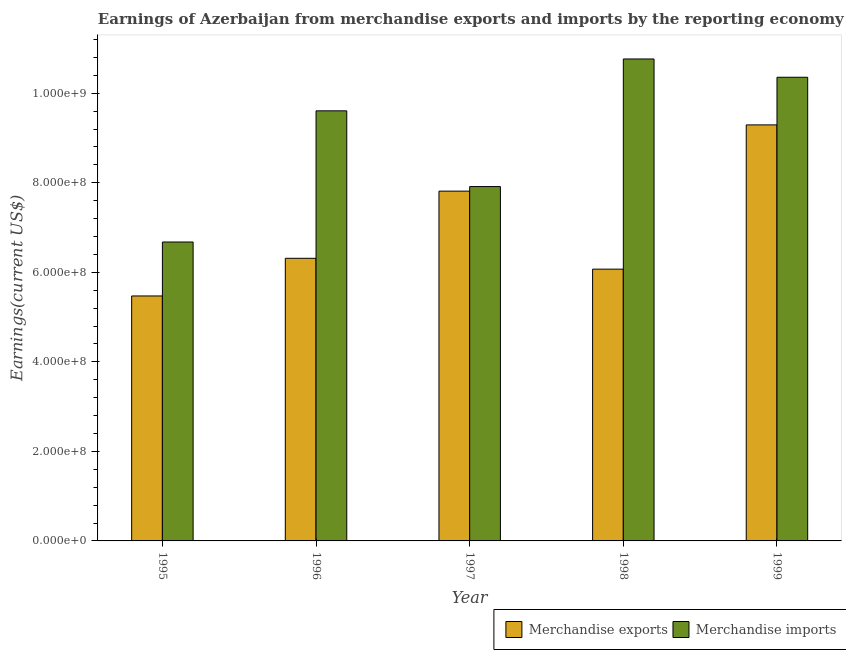How many different coloured bars are there?
Offer a very short reply. 2. How many groups of bars are there?
Keep it short and to the point. 5. What is the label of the 4th group of bars from the left?
Offer a very short reply. 1998. What is the earnings from merchandise imports in 1999?
Your answer should be very brief. 1.04e+09. Across all years, what is the maximum earnings from merchandise imports?
Provide a short and direct response. 1.08e+09. Across all years, what is the minimum earnings from merchandise exports?
Your answer should be compact. 5.47e+08. In which year was the earnings from merchandise exports maximum?
Offer a terse response. 1999. What is the total earnings from merchandise exports in the graph?
Your answer should be compact. 3.50e+09. What is the difference between the earnings from merchandise imports in 1995 and that in 1997?
Your answer should be very brief. -1.24e+08. What is the difference between the earnings from merchandise imports in 1997 and the earnings from merchandise exports in 1999?
Give a very brief answer. -2.44e+08. What is the average earnings from merchandise imports per year?
Offer a terse response. 9.06e+08. In how many years, is the earnings from merchandise exports greater than 480000000 US$?
Your answer should be compact. 5. What is the ratio of the earnings from merchandise imports in 1995 to that in 1998?
Offer a terse response. 0.62. Is the earnings from merchandise exports in 1995 less than that in 1996?
Your answer should be compact. Yes. What is the difference between the highest and the second highest earnings from merchandise exports?
Offer a very short reply. 1.48e+08. What is the difference between the highest and the lowest earnings from merchandise exports?
Offer a very short reply. 3.82e+08. In how many years, is the earnings from merchandise exports greater than the average earnings from merchandise exports taken over all years?
Keep it short and to the point. 2. Is the sum of the earnings from merchandise exports in 1995 and 1998 greater than the maximum earnings from merchandise imports across all years?
Your response must be concise. Yes. What does the 2nd bar from the left in 1995 represents?
Give a very brief answer. Merchandise imports. What does the 2nd bar from the right in 1996 represents?
Provide a succinct answer. Merchandise exports. How many bars are there?
Ensure brevity in your answer.  10. What is the difference between two consecutive major ticks on the Y-axis?
Offer a very short reply. 2.00e+08. Are the values on the major ticks of Y-axis written in scientific E-notation?
Make the answer very short. Yes. Does the graph contain any zero values?
Keep it short and to the point. No. Does the graph contain grids?
Your response must be concise. No. How many legend labels are there?
Offer a terse response. 2. What is the title of the graph?
Provide a succinct answer. Earnings of Azerbaijan from merchandise exports and imports by the reporting economy. What is the label or title of the X-axis?
Offer a very short reply. Year. What is the label or title of the Y-axis?
Offer a very short reply. Earnings(current US$). What is the Earnings(current US$) of Merchandise exports in 1995?
Your answer should be very brief. 5.47e+08. What is the Earnings(current US$) of Merchandise imports in 1995?
Your answer should be very brief. 6.68e+08. What is the Earnings(current US$) in Merchandise exports in 1996?
Make the answer very short. 6.31e+08. What is the Earnings(current US$) in Merchandise imports in 1996?
Make the answer very short. 9.61e+08. What is the Earnings(current US$) in Merchandise exports in 1997?
Make the answer very short. 7.81e+08. What is the Earnings(current US$) in Merchandise imports in 1997?
Provide a short and direct response. 7.91e+08. What is the Earnings(current US$) of Merchandise exports in 1998?
Give a very brief answer. 6.07e+08. What is the Earnings(current US$) in Merchandise imports in 1998?
Keep it short and to the point. 1.08e+09. What is the Earnings(current US$) in Merchandise exports in 1999?
Offer a very short reply. 9.29e+08. What is the Earnings(current US$) of Merchandise imports in 1999?
Make the answer very short. 1.04e+09. Across all years, what is the maximum Earnings(current US$) in Merchandise exports?
Provide a short and direct response. 9.29e+08. Across all years, what is the maximum Earnings(current US$) in Merchandise imports?
Ensure brevity in your answer.  1.08e+09. Across all years, what is the minimum Earnings(current US$) of Merchandise exports?
Provide a succinct answer. 5.47e+08. Across all years, what is the minimum Earnings(current US$) in Merchandise imports?
Make the answer very short. 6.68e+08. What is the total Earnings(current US$) in Merchandise exports in the graph?
Your answer should be very brief. 3.50e+09. What is the total Earnings(current US$) of Merchandise imports in the graph?
Offer a very short reply. 4.53e+09. What is the difference between the Earnings(current US$) in Merchandise exports in 1995 and that in 1996?
Make the answer very short. -8.41e+07. What is the difference between the Earnings(current US$) in Merchandise imports in 1995 and that in 1996?
Your answer should be very brief. -2.93e+08. What is the difference between the Earnings(current US$) in Merchandise exports in 1995 and that in 1997?
Provide a short and direct response. -2.34e+08. What is the difference between the Earnings(current US$) in Merchandise imports in 1995 and that in 1997?
Your answer should be compact. -1.24e+08. What is the difference between the Earnings(current US$) in Merchandise exports in 1995 and that in 1998?
Offer a terse response. -5.99e+07. What is the difference between the Earnings(current US$) in Merchandise imports in 1995 and that in 1998?
Keep it short and to the point. -4.09e+08. What is the difference between the Earnings(current US$) of Merchandise exports in 1995 and that in 1999?
Your answer should be very brief. -3.82e+08. What is the difference between the Earnings(current US$) of Merchandise imports in 1995 and that in 1999?
Your answer should be very brief. -3.68e+08. What is the difference between the Earnings(current US$) in Merchandise exports in 1996 and that in 1997?
Provide a short and direct response. -1.50e+08. What is the difference between the Earnings(current US$) in Merchandise imports in 1996 and that in 1997?
Your answer should be very brief. 1.69e+08. What is the difference between the Earnings(current US$) in Merchandise exports in 1996 and that in 1998?
Keep it short and to the point. 2.42e+07. What is the difference between the Earnings(current US$) of Merchandise imports in 1996 and that in 1998?
Your answer should be very brief. -1.16e+08. What is the difference between the Earnings(current US$) in Merchandise exports in 1996 and that in 1999?
Provide a succinct answer. -2.98e+08. What is the difference between the Earnings(current US$) of Merchandise imports in 1996 and that in 1999?
Keep it short and to the point. -7.50e+07. What is the difference between the Earnings(current US$) of Merchandise exports in 1997 and that in 1998?
Ensure brevity in your answer.  1.74e+08. What is the difference between the Earnings(current US$) in Merchandise imports in 1997 and that in 1998?
Provide a succinct answer. -2.85e+08. What is the difference between the Earnings(current US$) of Merchandise exports in 1997 and that in 1999?
Offer a very short reply. -1.48e+08. What is the difference between the Earnings(current US$) in Merchandise imports in 1997 and that in 1999?
Provide a short and direct response. -2.44e+08. What is the difference between the Earnings(current US$) of Merchandise exports in 1998 and that in 1999?
Provide a short and direct response. -3.22e+08. What is the difference between the Earnings(current US$) of Merchandise imports in 1998 and that in 1999?
Give a very brief answer. 4.08e+07. What is the difference between the Earnings(current US$) in Merchandise exports in 1995 and the Earnings(current US$) in Merchandise imports in 1996?
Offer a terse response. -4.13e+08. What is the difference between the Earnings(current US$) of Merchandise exports in 1995 and the Earnings(current US$) of Merchandise imports in 1997?
Keep it short and to the point. -2.44e+08. What is the difference between the Earnings(current US$) of Merchandise exports in 1995 and the Earnings(current US$) of Merchandise imports in 1998?
Offer a very short reply. -5.29e+08. What is the difference between the Earnings(current US$) of Merchandise exports in 1995 and the Earnings(current US$) of Merchandise imports in 1999?
Provide a succinct answer. -4.89e+08. What is the difference between the Earnings(current US$) in Merchandise exports in 1996 and the Earnings(current US$) in Merchandise imports in 1997?
Ensure brevity in your answer.  -1.60e+08. What is the difference between the Earnings(current US$) of Merchandise exports in 1996 and the Earnings(current US$) of Merchandise imports in 1998?
Your response must be concise. -4.45e+08. What is the difference between the Earnings(current US$) in Merchandise exports in 1996 and the Earnings(current US$) in Merchandise imports in 1999?
Ensure brevity in your answer.  -4.04e+08. What is the difference between the Earnings(current US$) of Merchandise exports in 1997 and the Earnings(current US$) of Merchandise imports in 1998?
Offer a terse response. -2.95e+08. What is the difference between the Earnings(current US$) in Merchandise exports in 1997 and the Earnings(current US$) in Merchandise imports in 1999?
Offer a very short reply. -2.54e+08. What is the difference between the Earnings(current US$) of Merchandise exports in 1998 and the Earnings(current US$) of Merchandise imports in 1999?
Ensure brevity in your answer.  -4.29e+08. What is the average Earnings(current US$) in Merchandise exports per year?
Ensure brevity in your answer.  6.99e+08. What is the average Earnings(current US$) of Merchandise imports per year?
Provide a succinct answer. 9.06e+08. In the year 1995, what is the difference between the Earnings(current US$) in Merchandise exports and Earnings(current US$) in Merchandise imports?
Provide a short and direct response. -1.21e+08. In the year 1996, what is the difference between the Earnings(current US$) of Merchandise exports and Earnings(current US$) of Merchandise imports?
Provide a succinct answer. -3.29e+08. In the year 1997, what is the difference between the Earnings(current US$) of Merchandise exports and Earnings(current US$) of Merchandise imports?
Offer a terse response. -1.02e+07. In the year 1998, what is the difference between the Earnings(current US$) in Merchandise exports and Earnings(current US$) in Merchandise imports?
Your response must be concise. -4.69e+08. In the year 1999, what is the difference between the Earnings(current US$) of Merchandise exports and Earnings(current US$) of Merchandise imports?
Your answer should be very brief. -1.06e+08. What is the ratio of the Earnings(current US$) in Merchandise exports in 1995 to that in 1996?
Make the answer very short. 0.87. What is the ratio of the Earnings(current US$) in Merchandise imports in 1995 to that in 1996?
Your response must be concise. 0.69. What is the ratio of the Earnings(current US$) of Merchandise exports in 1995 to that in 1997?
Your answer should be very brief. 0.7. What is the ratio of the Earnings(current US$) in Merchandise imports in 1995 to that in 1997?
Make the answer very short. 0.84. What is the ratio of the Earnings(current US$) of Merchandise exports in 1995 to that in 1998?
Provide a short and direct response. 0.9. What is the ratio of the Earnings(current US$) in Merchandise imports in 1995 to that in 1998?
Offer a terse response. 0.62. What is the ratio of the Earnings(current US$) in Merchandise exports in 1995 to that in 1999?
Provide a short and direct response. 0.59. What is the ratio of the Earnings(current US$) of Merchandise imports in 1995 to that in 1999?
Provide a succinct answer. 0.64. What is the ratio of the Earnings(current US$) in Merchandise exports in 1996 to that in 1997?
Make the answer very short. 0.81. What is the ratio of the Earnings(current US$) in Merchandise imports in 1996 to that in 1997?
Give a very brief answer. 1.21. What is the ratio of the Earnings(current US$) of Merchandise exports in 1996 to that in 1998?
Your response must be concise. 1.04. What is the ratio of the Earnings(current US$) in Merchandise imports in 1996 to that in 1998?
Make the answer very short. 0.89. What is the ratio of the Earnings(current US$) in Merchandise exports in 1996 to that in 1999?
Give a very brief answer. 0.68. What is the ratio of the Earnings(current US$) in Merchandise imports in 1996 to that in 1999?
Give a very brief answer. 0.93. What is the ratio of the Earnings(current US$) in Merchandise exports in 1997 to that in 1998?
Make the answer very short. 1.29. What is the ratio of the Earnings(current US$) in Merchandise imports in 1997 to that in 1998?
Ensure brevity in your answer.  0.74. What is the ratio of the Earnings(current US$) of Merchandise exports in 1997 to that in 1999?
Ensure brevity in your answer.  0.84. What is the ratio of the Earnings(current US$) in Merchandise imports in 1997 to that in 1999?
Ensure brevity in your answer.  0.76. What is the ratio of the Earnings(current US$) in Merchandise exports in 1998 to that in 1999?
Provide a succinct answer. 0.65. What is the ratio of the Earnings(current US$) of Merchandise imports in 1998 to that in 1999?
Provide a short and direct response. 1.04. What is the difference between the highest and the second highest Earnings(current US$) in Merchandise exports?
Your answer should be very brief. 1.48e+08. What is the difference between the highest and the second highest Earnings(current US$) in Merchandise imports?
Provide a short and direct response. 4.08e+07. What is the difference between the highest and the lowest Earnings(current US$) in Merchandise exports?
Your response must be concise. 3.82e+08. What is the difference between the highest and the lowest Earnings(current US$) in Merchandise imports?
Your response must be concise. 4.09e+08. 